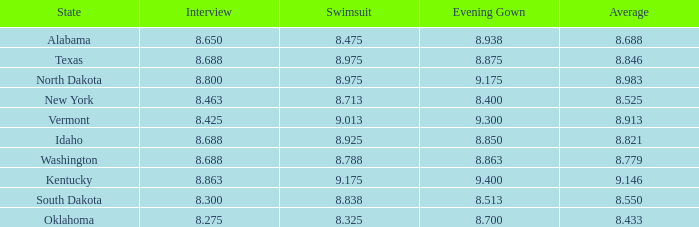What is the highest swimsuit score of the contestant with an evening gown larger than 9.175 and an interview score less than 8.425? None. 